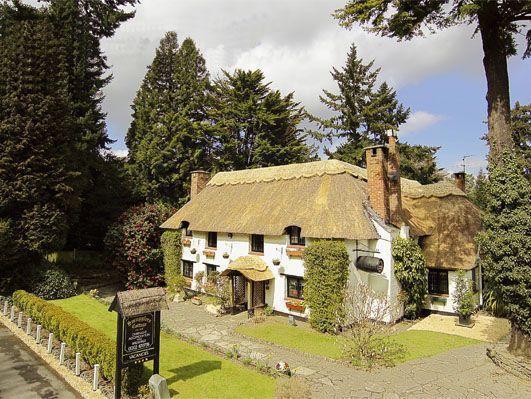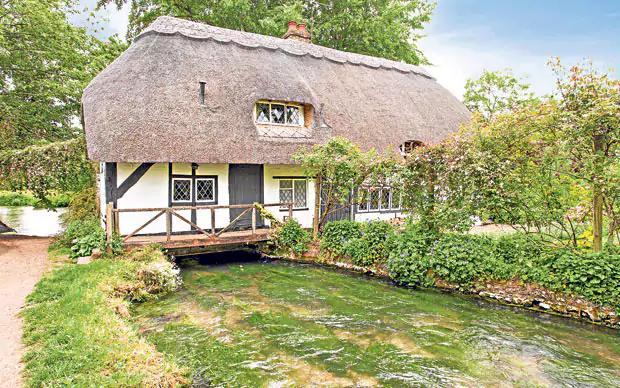The first image is the image on the left, the second image is the image on the right. Evaluate the accuracy of this statement regarding the images: "In the center of each image there is a house surrounded by a lot of green foliage and landscaping.". Is it true? Answer yes or no. Yes. 